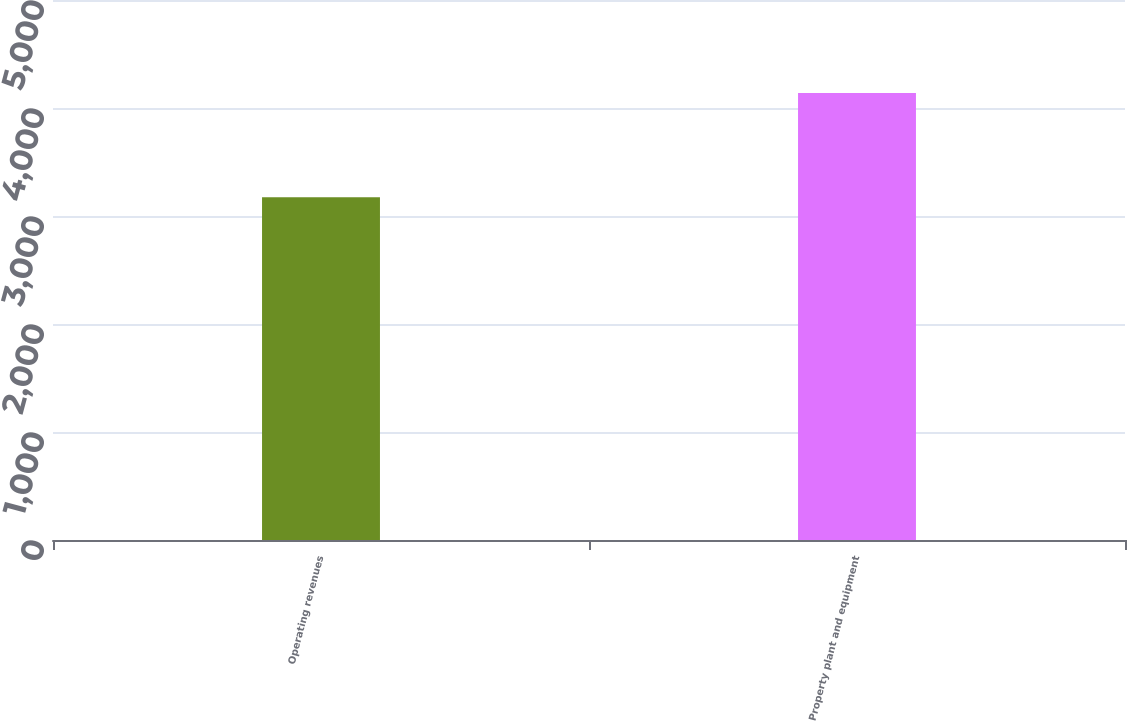Convert chart. <chart><loc_0><loc_0><loc_500><loc_500><bar_chart><fcel>Operating revenues<fcel>Property plant and equipment<nl><fcel>3173<fcel>4139<nl></chart> 